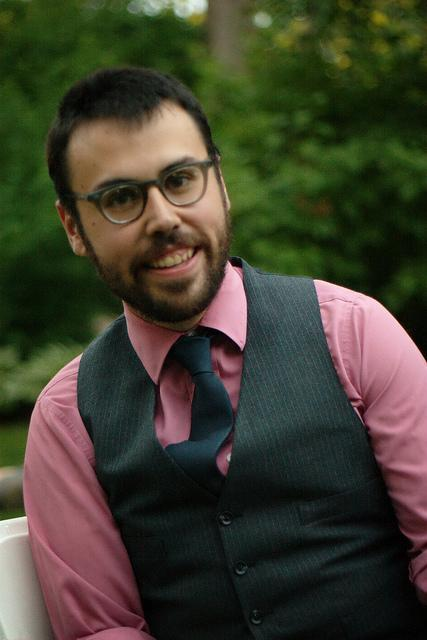Why is he smiling?

Choices:
A) is surprised
B) for camera
C) won money
D) is friendly for camera 